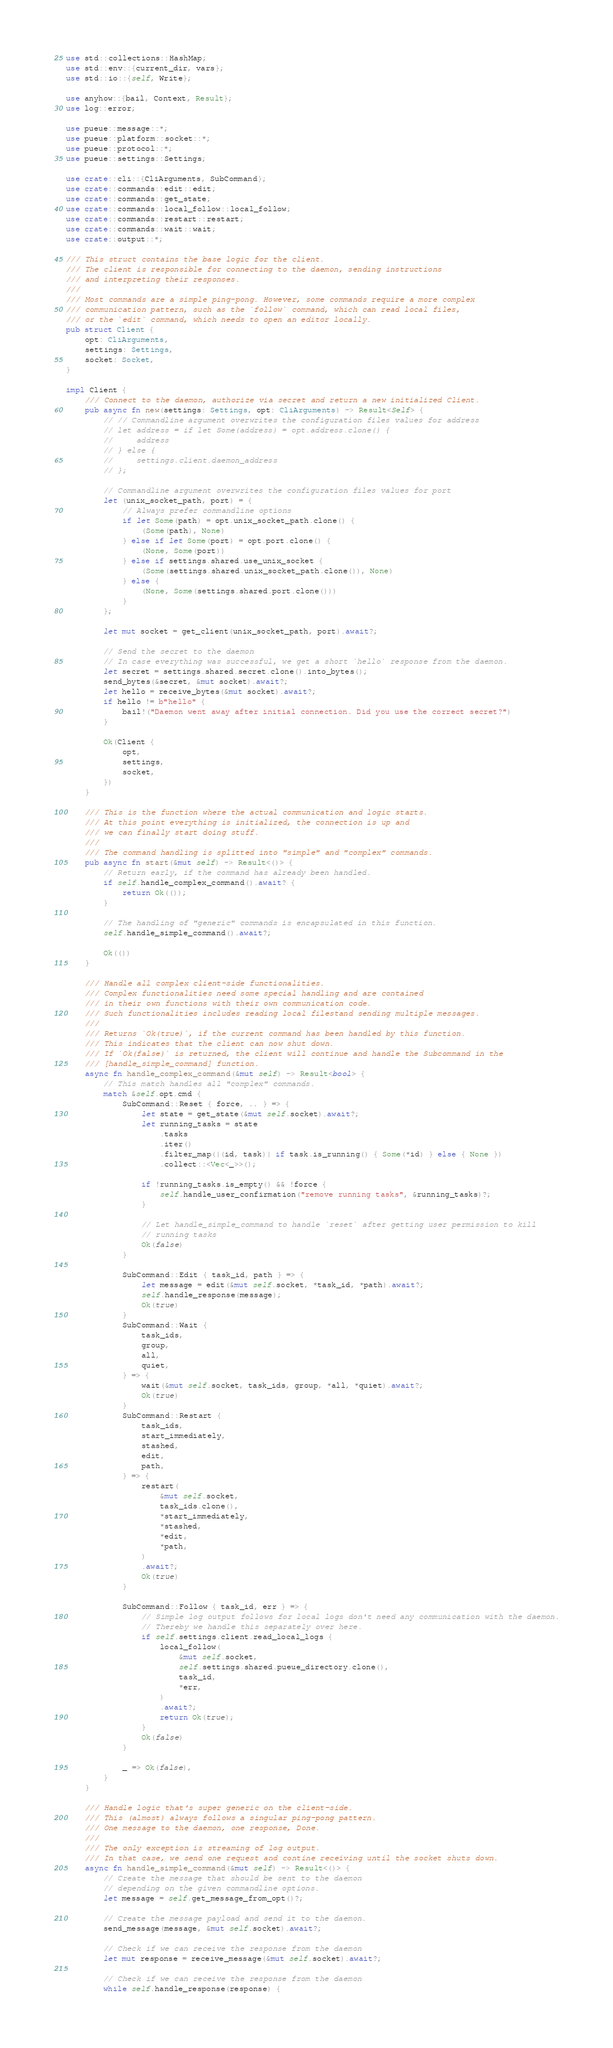<code> <loc_0><loc_0><loc_500><loc_500><_Rust_>use std::collections::HashMap;
use std::env::{current_dir, vars};
use std::io::{self, Write};

use anyhow::{bail, Context, Result};
use log::error;

use pueue::message::*;
use pueue::platform::socket::*;
use pueue::protocol::*;
use pueue::settings::Settings;

use crate::cli::{CliArguments, SubCommand};
use crate::commands::edit::edit;
use crate::commands::get_state;
use crate::commands::local_follow::local_follow;
use crate::commands::restart::restart;
use crate::commands::wait::wait;
use crate::output::*;

/// This struct contains the base logic for the client.
/// The client is responsible for connecting to the daemon, sending instructions
/// and interpreting their responses.
///
/// Most commands are a simple ping-pong. However, some commands require a more complex
/// communication pattern, such as the `follow` command, which can read local files,
/// or the `edit` command, which needs to open an editor locally.
pub struct Client {
    opt: CliArguments,
    settings: Settings,
    socket: Socket,
}

impl Client {
    /// Connect to the daemon, authorize via secret and return a new initialized Client.
    pub async fn new(settings: Settings, opt: CliArguments) -> Result<Self> {
        // // Commandline argument overwrites the configuration files values for address
        // let address = if let Some(address) = opt.address.clone() {
        //     address
        // } else {
        //     settings.client.daemon_address
        // };

        // Commandline argument overwrites the configuration files values for port
        let (unix_socket_path, port) = {
            // Always prefer commandline options
            if let Some(path) = opt.unix_socket_path.clone() {
                (Some(path), None)
            } else if let Some(port) = opt.port.clone() {
                (None, Some(port))
            } else if settings.shared.use_unix_socket {
                (Some(settings.shared.unix_socket_path.clone()), None)
            } else {
                (None, Some(settings.shared.port.clone()))
            }
        };

        let mut socket = get_client(unix_socket_path, port).await?;

        // Send the secret to the daemon
        // In case everything was successful, we get a short `hello` response from the daemon.
        let secret = settings.shared.secret.clone().into_bytes();
        send_bytes(&secret, &mut socket).await?;
        let hello = receive_bytes(&mut socket).await?;
        if hello != b"hello" {
            bail!("Daemon went away after initial connection. Did you use the correct secret?")
        }

        Ok(Client {
            opt,
            settings,
            socket,
        })
    }

    /// This is the function where the actual communication and logic starts.
    /// At this point everything is initialized, the connection is up and
    /// we can finally start doing stuff.
    ///
    /// The command handling is splitted into "simple" and "complex" commands.
    pub async fn start(&mut self) -> Result<()> {
        // Return early, if the command has already been handled.
        if self.handle_complex_command().await? {
            return Ok(());
        }

        // The handling of "generic" commands is encapsulated in this function.
        self.handle_simple_command().await?;

        Ok(())
    }

    /// Handle all complex client-side functionalities.
    /// Complex functionalities need some special handling and are contained
    /// in their own functions with their own communication code.
    /// Such functionalities includes reading local filestand sending multiple messages.
    ///
    /// Returns `Ok(true)`, if the current command has been handled by this function.
    /// This indicates that the client can now shut down.
    /// If `Ok(false)` is returned, the client will continue and handle the Subcommand in the
    /// [handle_simple_command] function.
    async fn handle_complex_command(&mut self) -> Result<bool> {
        // This match handles all "complex" commands.
        match &self.opt.cmd {
            SubCommand::Reset { force, .. } => {
                let state = get_state(&mut self.socket).await?;
                let running_tasks = state
                    .tasks
                    .iter()
                    .filter_map(|(id, task)| if task.is_running() { Some(*id) } else { None })
                    .collect::<Vec<_>>();

                if !running_tasks.is_empty() && !force {
                    self.handle_user_confirmation("remove running tasks", &running_tasks)?;
                }

                // Let handle_simple_command to handle `reset` after getting user permission to kill
                // running tasks
                Ok(false)
            }

            SubCommand::Edit { task_id, path } => {
                let message = edit(&mut self.socket, *task_id, *path).await?;
                self.handle_response(message);
                Ok(true)
            }
            SubCommand::Wait {
                task_ids,
                group,
                all,
                quiet,
            } => {
                wait(&mut self.socket, task_ids, group, *all, *quiet).await?;
                Ok(true)
            }
            SubCommand::Restart {
                task_ids,
                start_immediately,
                stashed,
                edit,
                path,
            } => {
                restart(
                    &mut self.socket,
                    task_ids.clone(),
                    *start_immediately,
                    *stashed,
                    *edit,
                    *path,
                )
                .await?;
                Ok(true)
            }

            SubCommand::Follow { task_id, err } => {
                // Simple log output follows for local logs don't need any communication with the daemon.
                // Thereby we handle this separately over here.
                if self.settings.client.read_local_logs {
                    local_follow(
                        &mut self.socket,
                        self.settings.shared.pueue_directory.clone(),
                        task_id,
                        *err,
                    )
                    .await?;
                    return Ok(true);
                }
                Ok(false)
            }

            _ => Ok(false),
        }
    }

    /// Handle logic that's super generic on the client-side.
    /// This (almost) always follows a singular ping-pong pattern.
    /// One message to the daemon, one response, Done.
    ///
    /// The only exception is streaming of log output.
    /// In that case, we send one request and contine receiving until the socket shuts down.
    async fn handle_simple_command(&mut self) -> Result<()> {
        // Create the message that should be sent to the daemon
        // depending on the given commandline options.
        let message = self.get_message_from_opt()?;

        // Create the message payload and send it to the daemon.
        send_message(message, &mut self.socket).await?;

        // Check if we can receive the response from the daemon
        let mut response = receive_message(&mut self.socket).await?;

        // Check if we can receive the response from the daemon
        while self.handle_response(response) {</code> 